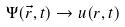<formula> <loc_0><loc_0><loc_500><loc_500>\Psi ( \vec { r } , t ) \rightarrow u ( r , t )</formula> 